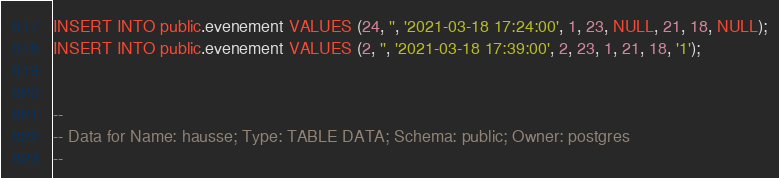Convert code to text. <code><loc_0><loc_0><loc_500><loc_500><_SQL_>INSERT INTO public.evenement VALUES (24, '', '2021-03-18 17:24:00', 1, 23, NULL, 21, 18, NULL);
INSERT INTO public.evenement VALUES (2, '', '2021-03-18 17:39:00', 2, 23, 1, 21, 18, '1');


--
-- Data for Name: hausse; Type: TABLE DATA; Schema: public; Owner: postgres
--
</code> 